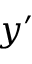<formula> <loc_0><loc_0><loc_500><loc_500>y ^ { \prime }</formula> 